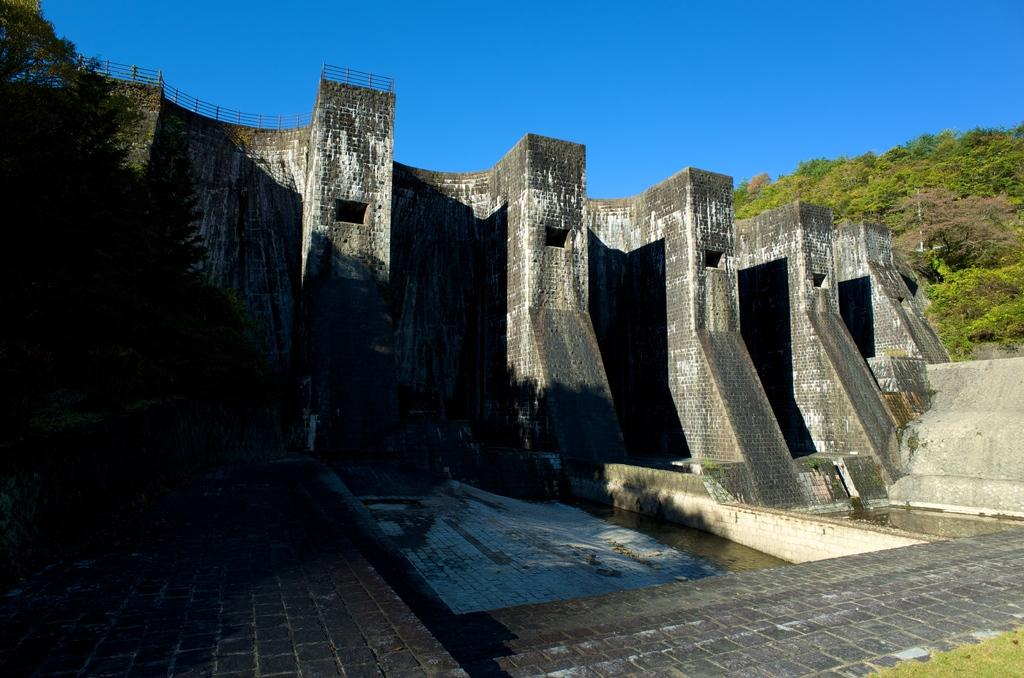What is the main subject of the image? There is a dam in the image. What can be seen in the background of the image? There are trees and the sky visible in the background of the image. What type of treatment is being administered to the dam in the image? There is no treatment being administered to the dam in the image; it is a static structure. 